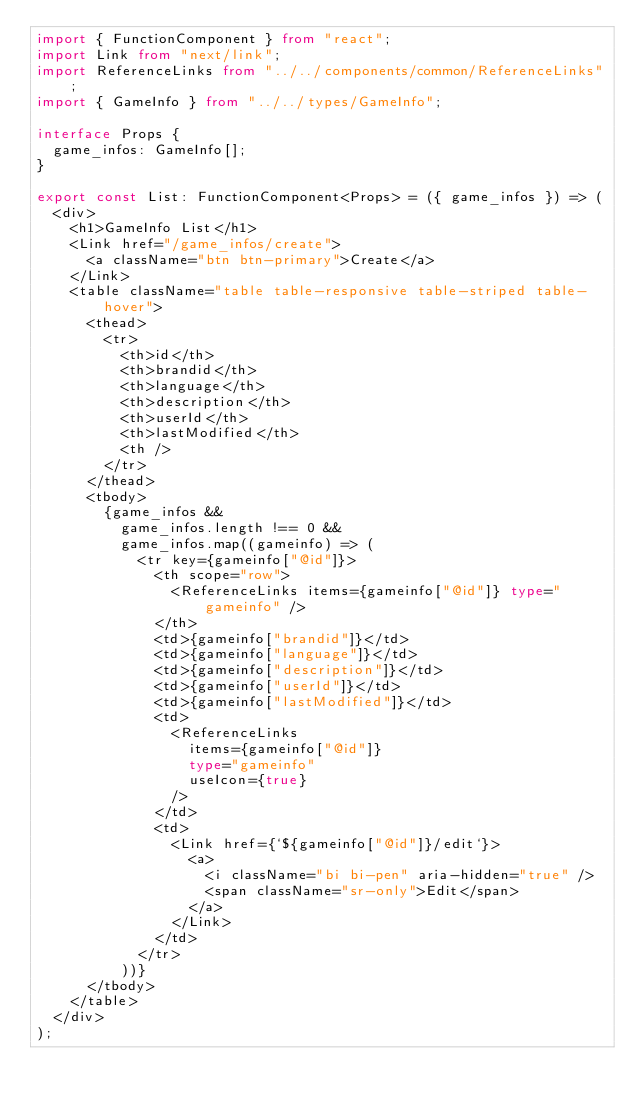Convert code to text. <code><loc_0><loc_0><loc_500><loc_500><_TypeScript_>import { FunctionComponent } from "react";
import Link from "next/link";
import ReferenceLinks from "../../components/common/ReferenceLinks";
import { GameInfo } from "../../types/GameInfo";

interface Props {
  game_infos: GameInfo[];
}

export const List: FunctionComponent<Props> = ({ game_infos }) => (
  <div>
    <h1>GameInfo List</h1>
    <Link href="/game_infos/create">
      <a className="btn btn-primary">Create</a>
    </Link>
    <table className="table table-responsive table-striped table-hover">
      <thead>
        <tr>
          <th>id</th>
          <th>brandid</th>
          <th>language</th>
          <th>description</th>
          <th>userId</th>
          <th>lastModified</th>
          <th />
        </tr>
      </thead>
      <tbody>
        {game_infos &&
          game_infos.length !== 0 &&
          game_infos.map((gameinfo) => (
            <tr key={gameinfo["@id"]}>
              <th scope="row">
                <ReferenceLinks items={gameinfo["@id"]} type="gameinfo" />
              </th>
              <td>{gameinfo["brandid"]}</td>
              <td>{gameinfo["language"]}</td>
              <td>{gameinfo["description"]}</td>
              <td>{gameinfo["userId"]}</td>
              <td>{gameinfo["lastModified"]}</td>
              <td>
                <ReferenceLinks
                  items={gameinfo["@id"]}
                  type="gameinfo"
                  useIcon={true}
                />
              </td>
              <td>
                <Link href={`${gameinfo["@id"]}/edit`}>
                  <a>
                    <i className="bi bi-pen" aria-hidden="true" />
                    <span className="sr-only">Edit</span>
                  </a>
                </Link>
              </td>
            </tr>
          ))}
      </tbody>
    </table>
  </div>
);
</code> 